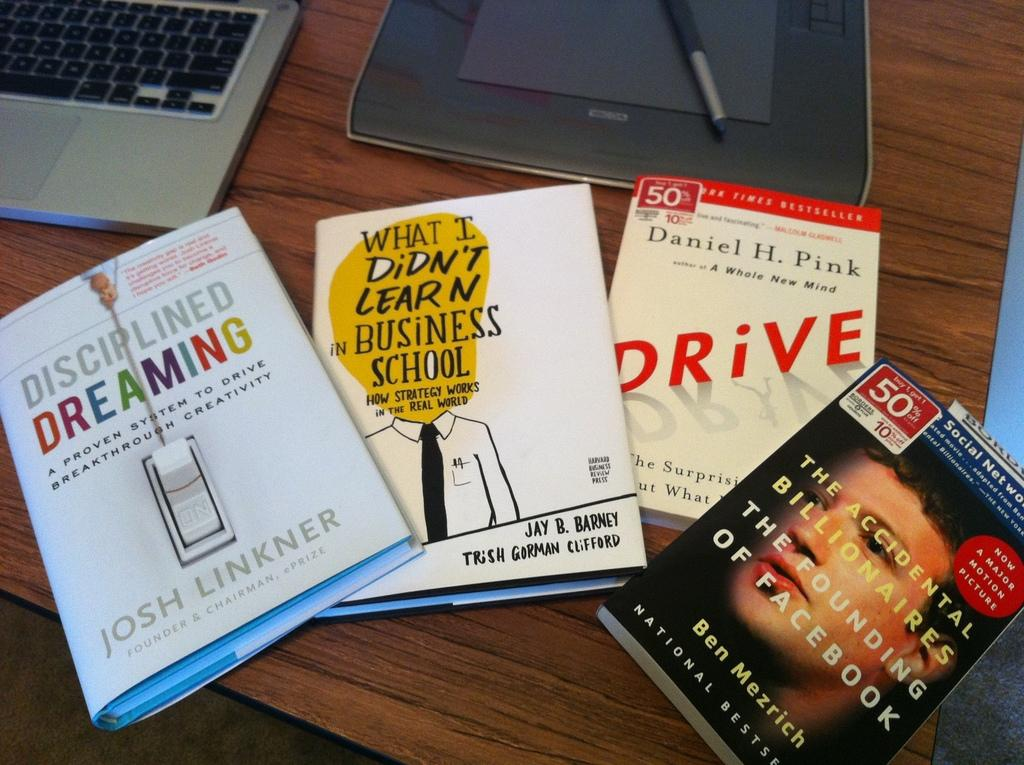<image>
Relay a brief, clear account of the picture shown. One of the several books on the table is titled Drive. 